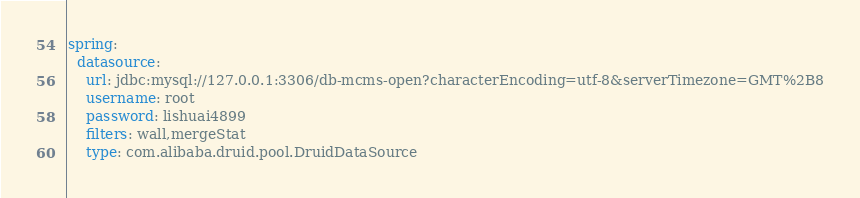Convert code to text. <code><loc_0><loc_0><loc_500><loc_500><_YAML_>spring:
  datasource:
    url: jdbc:mysql://127.0.0.1:3306/db-mcms-open?characterEncoding=utf-8&serverTimezone=GMT%2B8
    username: root
    password: lishuai4899
    filters: wall,mergeStat
    type: com.alibaba.druid.pool.DruidDataSource
</code> 